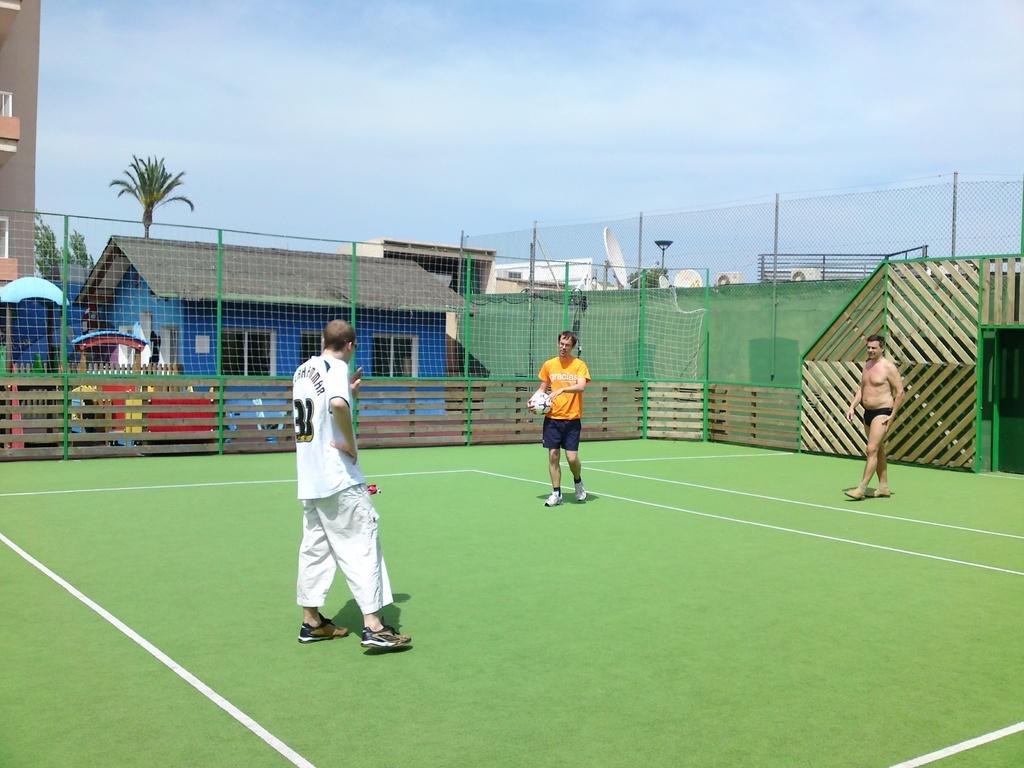Could you give a brief overview of what you see in this image? At the top we can see sky. On the background we can see building, house, trees. This is a mesh. We can see persons in a ground. This man wearing orange colour t shirt holding a ball in his hand. 